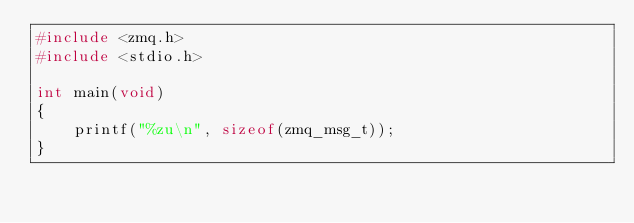<code> <loc_0><loc_0><loc_500><loc_500><_C_>#include <zmq.h>
#include <stdio.h>

int main(void)
{
    printf("%zu\n", sizeof(zmq_msg_t));
}
</code> 